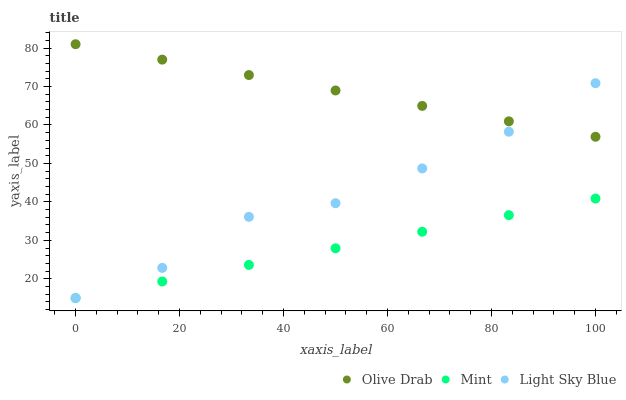Does Mint have the minimum area under the curve?
Answer yes or no. Yes. Does Olive Drab have the maximum area under the curve?
Answer yes or no. Yes. Does Olive Drab have the minimum area under the curve?
Answer yes or no. No. Does Mint have the maximum area under the curve?
Answer yes or no. No. Is Mint the smoothest?
Answer yes or no. Yes. Is Light Sky Blue the roughest?
Answer yes or no. Yes. Is Olive Drab the smoothest?
Answer yes or no. No. Is Olive Drab the roughest?
Answer yes or no. No. Does Light Sky Blue have the lowest value?
Answer yes or no. Yes. Does Olive Drab have the lowest value?
Answer yes or no. No. Does Olive Drab have the highest value?
Answer yes or no. Yes. Does Mint have the highest value?
Answer yes or no. No. Is Mint less than Olive Drab?
Answer yes or no. Yes. Is Olive Drab greater than Mint?
Answer yes or no. Yes. Does Mint intersect Light Sky Blue?
Answer yes or no. Yes. Is Mint less than Light Sky Blue?
Answer yes or no. No. Is Mint greater than Light Sky Blue?
Answer yes or no. No. Does Mint intersect Olive Drab?
Answer yes or no. No. 